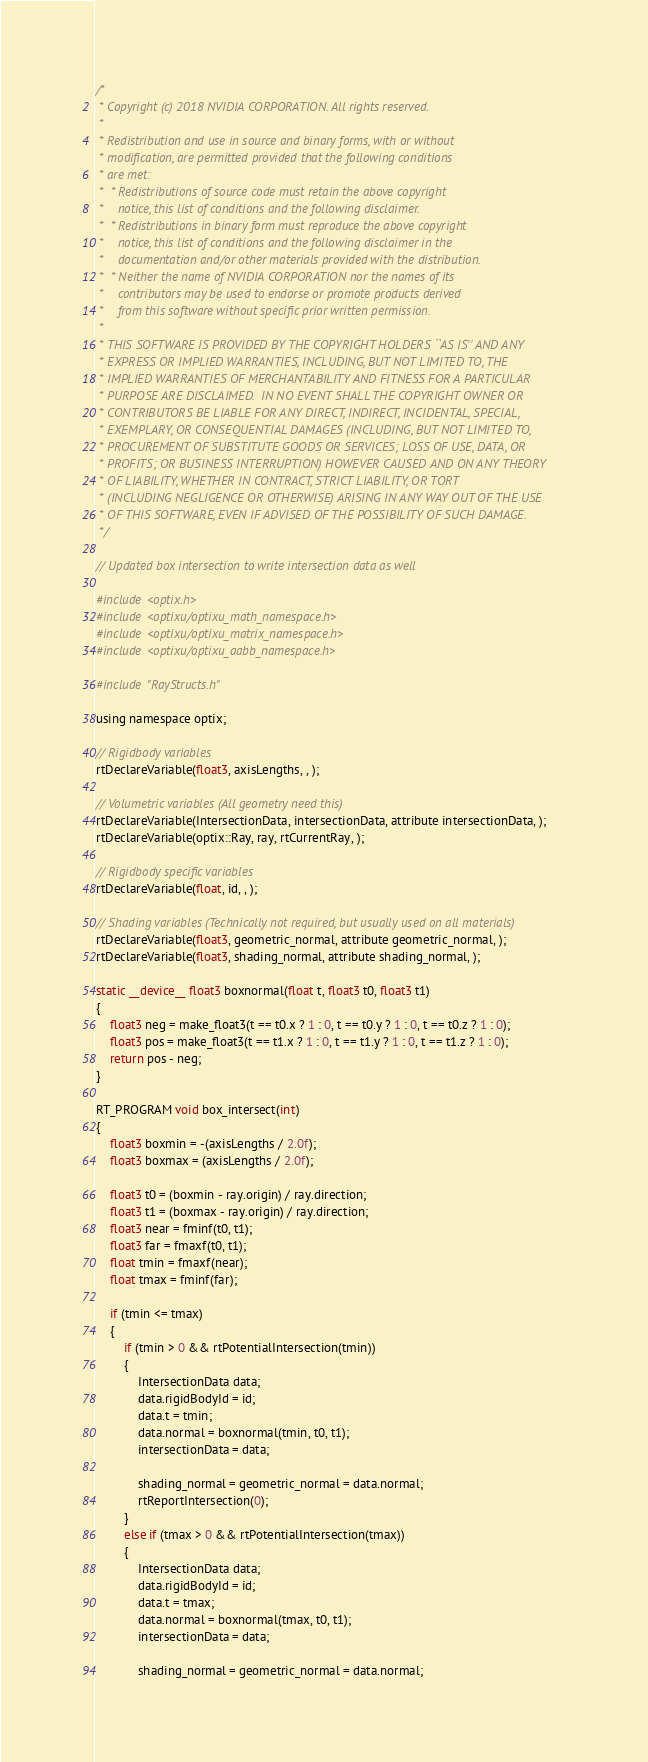Convert code to text. <code><loc_0><loc_0><loc_500><loc_500><_Cuda_>/*
 * Copyright (c) 2018 NVIDIA CORPORATION. All rights reserved.
 *
 * Redistribution and use in source and binary forms, with or without
 * modification, are permitted provided that the following conditions
 * are met:
 *  * Redistributions of source code must retain the above copyright
 *    notice, this list of conditions and the following disclaimer.
 *  * Redistributions in binary form must reproduce the above copyright
 *    notice, this list of conditions and the following disclaimer in the
 *    documentation and/or other materials provided with the distribution.
 *  * Neither the name of NVIDIA CORPORATION nor the names of its
 *    contributors may be used to endorse or promote products derived
 *    from this software without specific prior written permission.
 *
 * THIS SOFTWARE IS PROVIDED BY THE COPYRIGHT HOLDERS ``AS IS'' AND ANY
 * EXPRESS OR IMPLIED WARRANTIES, INCLUDING, BUT NOT LIMITED TO, THE
 * IMPLIED WARRANTIES OF MERCHANTABILITY AND FITNESS FOR A PARTICULAR
 * PURPOSE ARE DISCLAIMED.  IN NO EVENT SHALL THE COPYRIGHT OWNER OR
 * CONTRIBUTORS BE LIABLE FOR ANY DIRECT, INDIRECT, INCIDENTAL, SPECIAL,
 * EXEMPLARY, OR CONSEQUENTIAL DAMAGES (INCLUDING, BUT NOT LIMITED TO,
 * PROCUREMENT OF SUBSTITUTE GOODS OR SERVICES; LOSS OF USE, DATA, OR
 * PROFITS; OR BUSINESS INTERRUPTION) HOWEVER CAUSED AND ON ANY THEORY
 * OF LIABILITY, WHETHER IN CONTRACT, STRICT LIABILITY, OR TORT
 * (INCLUDING NEGLIGENCE OR OTHERWISE) ARISING IN ANY WAY OUT OF THE USE
 * OF THIS SOFTWARE, EVEN IF ADVISED OF THE POSSIBILITY OF SUCH DAMAGE.
 */

// Updated box intersection to write intersection data as well

#include <optix.h>
#include <optixu/optixu_math_namespace.h>
#include <optixu/optixu_matrix_namespace.h>
#include <optixu/optixu_aabb_namespace.h>

#include "RayStructs.h"

using namespace optix;

// Rigidbody variables
rtDeclareVariable(float3, axisLengths, , );

// Volumetric variables (All geometry need this)
rtDeclareVariable(IntersectionData, intersectionData, attribute intersectionData, );
rtDeclareVariable(optix::Ray, ray, rtCurrentRay, );

// Rigidbody specific variables
rtDeclareVariable(float, id, , );

// Shading variables (Technically not required, but usually used on all materials)
rtDeclareVariable(float3, geometric_normal, attribute geometric_normal, );
rtDeclareVariable(float3, shading_normal, attribute shading_normal, );

static __device__ float3 boxnormal(float t, float3 t0, float3 t1)
{
	float3 neg = make_float3(t == t0.x ? 1 : 0, t == t0.y ? 1 : 0, t == t0.z ? 1 : 0);
	float3 pos = make_float3(t == t1.x ? 1 : 0, t == t1.y ? 1 : 0, t == t1.z ? 1 : 0);
	return pos - neg;
}

RT_PROGRAM void box_intersect(int)
{
	float3 boxmin = -(axisLengths / 2.0f);
	float3 boxmax = (axisLengths / 2.0f);

	float3 t0 = (boxmin - ray.origin) / ray.direction;
	float3 t1 = (boxmax - ray.origin) / ray.direction;
	float3 near = fminf(t0, t1);
	float3 far = fmaxf(t0, t1);
	float tmin = fmaxf(near);
	float tmax = fminf(far);

	if (tmin <= tmax) 
	{
		if (tmin > 0 && rtPotentialIntersection(tmin)) 
		{
			IntersectionData data;
			data.rigidBodyId = id;
			data.t = tmin;
			data.normal = boxnormal(tmin, t0, t1);
			intersectionData = data;

			shading_normal = geometric_normal = data.normal;
			rtReportIntersection(0);
		}
		else if (tmax > 0 && rtPotentialIntersection(tmax))
		{
			IntersectionData data;
			data.rigidBodyId = id;
			data.t = tmax;
			data.normal = boxnormal(tmax, t0, t1);
			intersectionData = data;

			shading_normal = geometric_normal = data.normal;</code> 